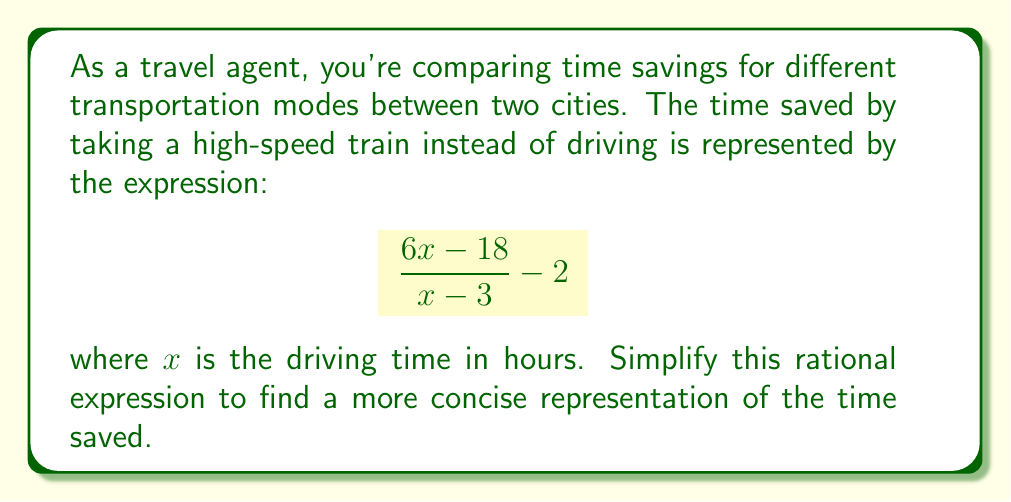Can you solve this math problem? Let's simplify this rational expression step by step:

1) First, let's focus on the fraction part: $\frac{6x - 18}{x - 3}$

2) We can factor out the greatest common factor in the numerator:
   $\frac{6(x - 3)}{x - 3}$

3) The $(x - 3)$ terms cancel out in the numerator and denominator:
   $\frac{6(x - 3)}{x - 3} = 6$

4) Now our expression looks like this: $6 - 2$

5) Simplify: $6 - 2 = 4$

Therefore, the simplified expression for the time saved is 4 hours, regardless of the driving time $x$ (as long as $x \neq 3$, to avoid division by zero in the original expression).
Answer: $4$ 